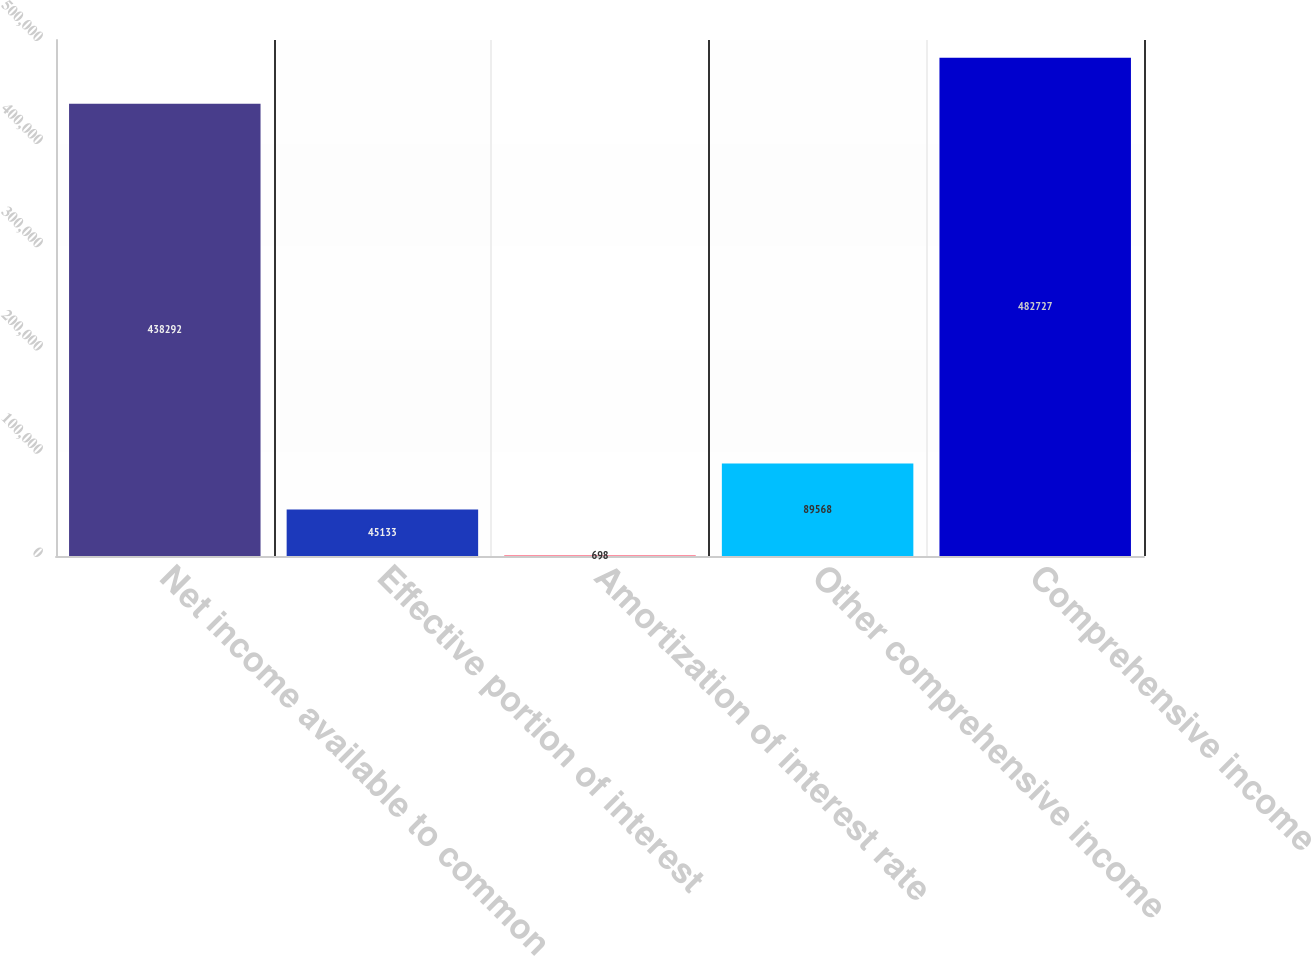Convert chart to OTSL. <chart><loc_0><loc_0><loc_500><loc_500><bar_chart><fcel>Net income available to common<fcel>Effective portion of interest<fcel>Amortization of interest rate<fcel>Other comprehensive income<fcel>Comprehensive income<nl><fcel>438292<fcel>45133<fcel>698<fcel>89568<fcel>482727<nl></chart> 